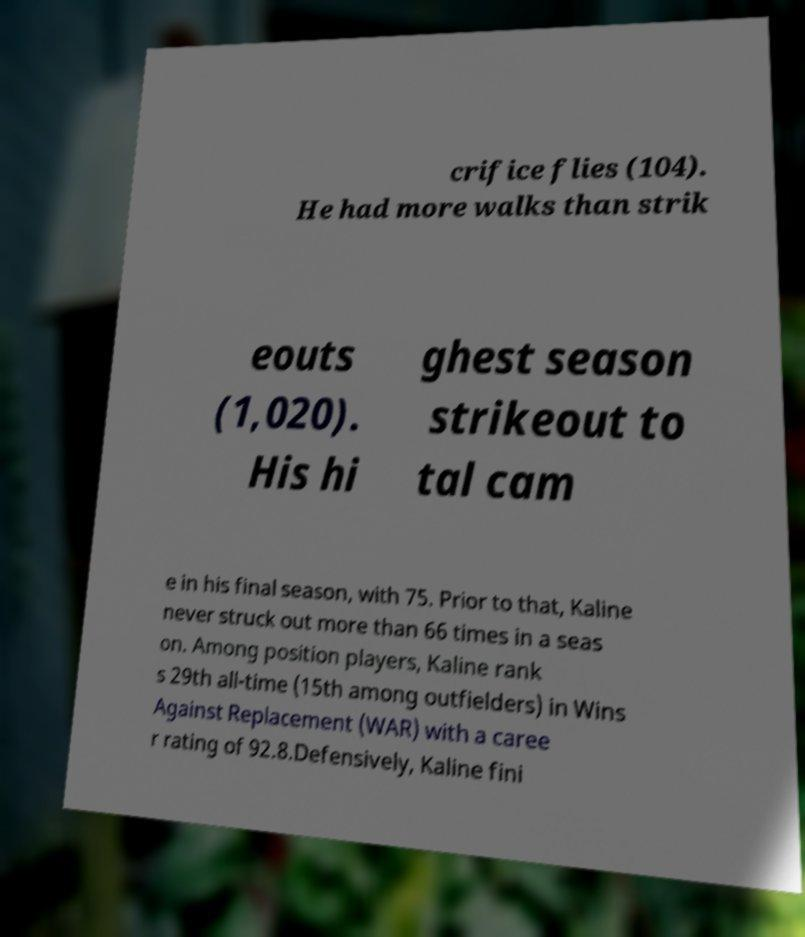For documentation purposes, I need the text within this image transcribed. Could you provide that? crifice flies (104). He had more walks than strik eouts (1,020). His hi ghest season strikeout to tal cam e in his final season, with 75. Prior to that, Kaline never struck out more than 66 times in a seas on. Among position players, Kaline rank s 29th all-time (15th among outfielders) in Wins Against Replacement (WAR) with a caree r rating of 92.8.Defensively, Kaline fini 